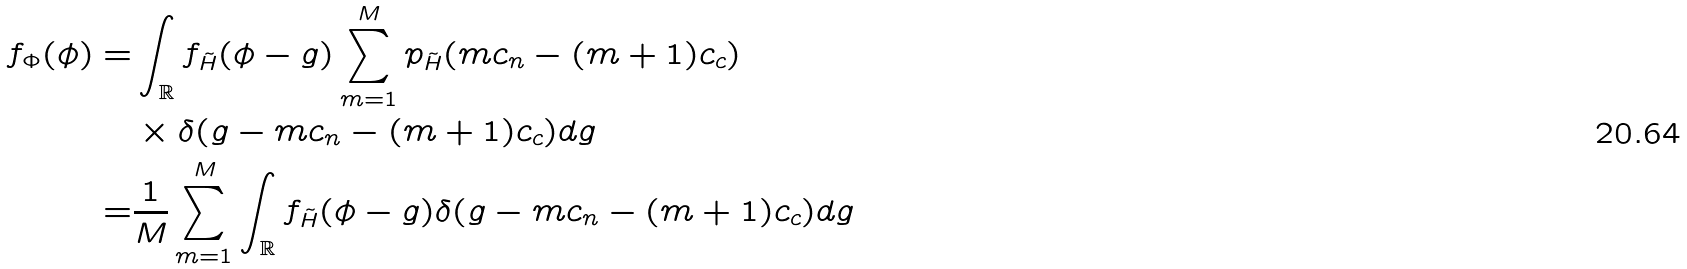<formula> <loc_0><loc_0><loc_500><loc_500>f _ { \Phi } ( \phi ) = & \int _ { \mathbb { R } } f _ { \tilde { H } } ( \phi - g ) \sum _ { m = 1 } ^ { M } p _ { \tilde { H } } ( m c _ { n } - ( m + 1 ) c _ { c } ) \\ & \times \delta ( g - m c _ { n } - ( m + 1 ) c _ { c } ) d g \\ = & \frac { 1 } { M } \sum _ { m = 1 } ^ { M } \int _ { \mathbb { R } } f _ { \tilde { H } } ( \phi - g ) \delta ( g - m c _ { n } - ( m + 1 ) c _ { c } ) d g</formula> 